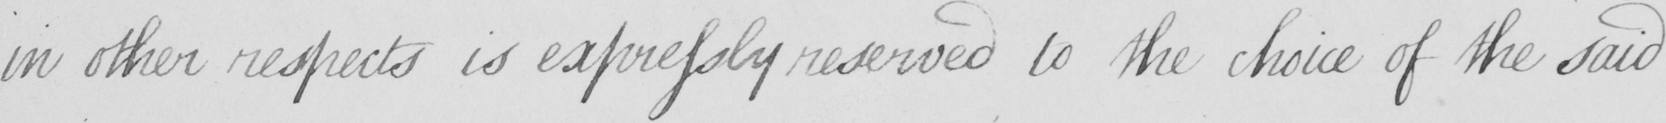Please provide the text content of this handwritten line. in other respects is expressly reserved to the choice of the said 